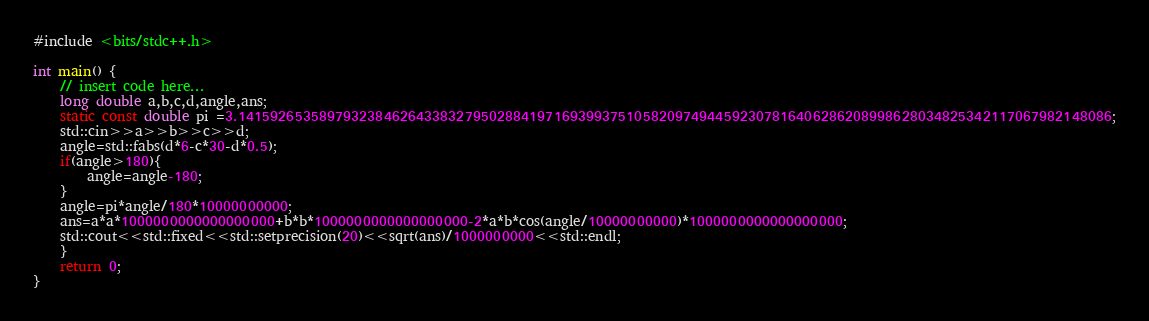<code> <loc_0><loc_0><loc_500><loc_500><_C++_>#include <bits/stdc++.h>

int main() {
    // insert code here...
    long double a,b,c,d,angle,ans;
    static const double pi =3.141592653589793238462643383279502884197169399375105820974944592307816406286208998628034825342117067982148086;
    std::cin>>a>>b>>c>>d;
    angle=std::fabs(d*6-c*30-d*0.5);
    if(angle>180){
        angle=angle-180;
    }
    angle=pi*angle/180*10000000000;
    ans=a*a*1000000000000000000+b*b*1000000000000000000-2*a*b*cos(angle/10000000000)*1000000000000000000;
    std::cout<<std::fixed<<std::setprecision(20)<<sqrt(ans)/1000000000<<std::endl;
    }
    return 0;
}</code> 